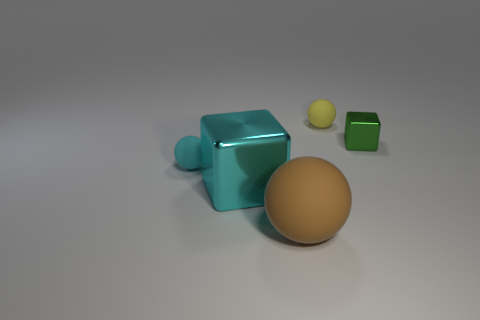Subtract all yellow rubber spheres. How many spheres are left? 2 Add 3 small gray matte balls. How many objects exist? 8 Subtract all purple balls. Subtract all gray cylinders. How many balls are left? 3 Add 3 small yellow spheres. How many small yellow spheres exist? 4 Subtract 0 yellow cubes. How many objects are left? 5 Subtract all spheres. How many objects are left? 2 Subtract all big brown shiny blocks. Subtract all cyan matte things. How many objects are left? 4 Add 1 big balls. How many big balls are left? 2 